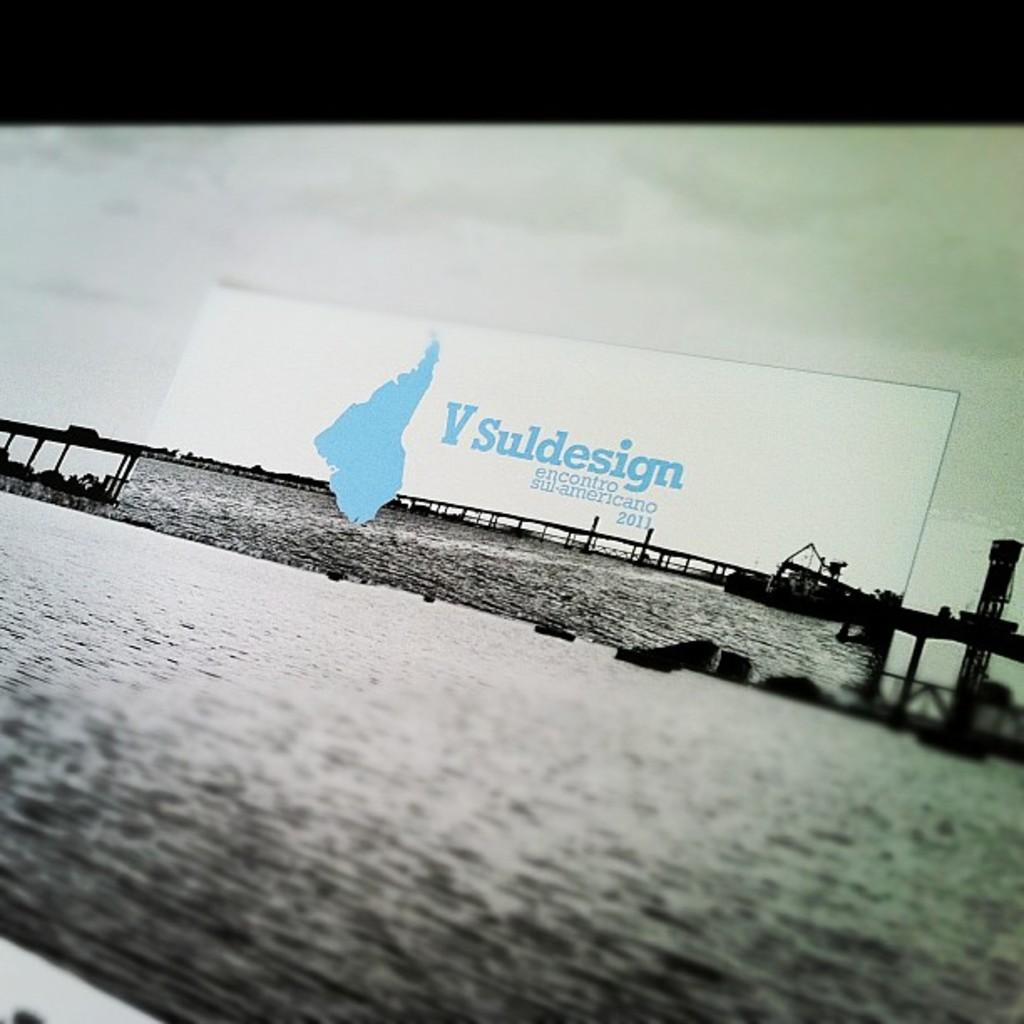<image>
Offer a succinct explanation of the picture presented. Vsuldesign encontro sul-americano 2011 blue and white banner above water. 